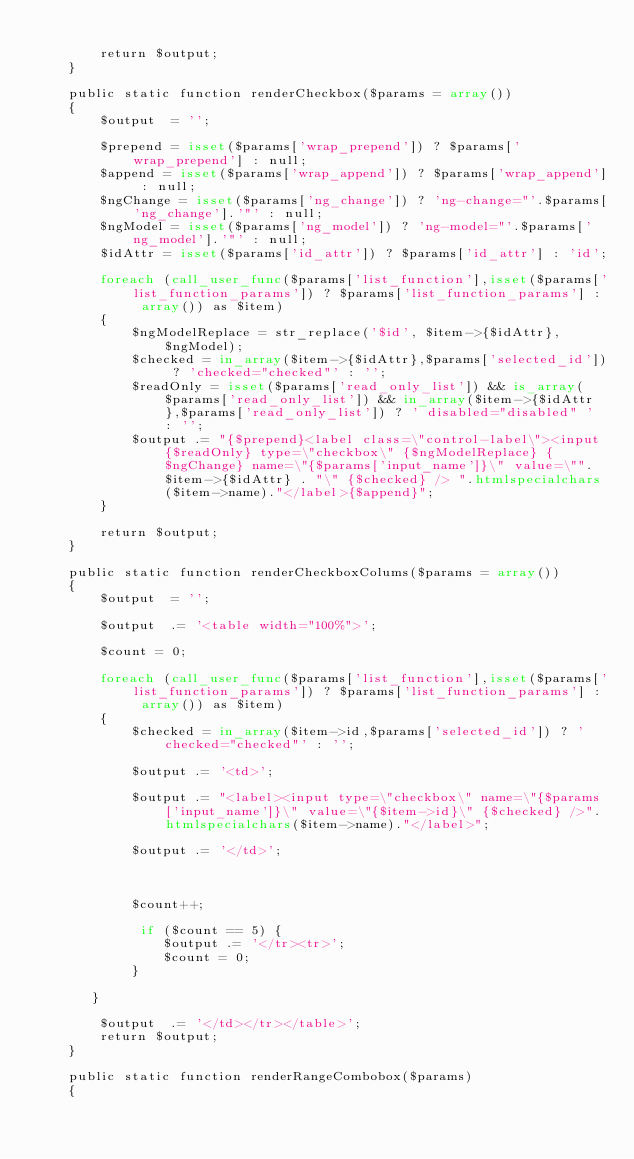<code> <loc_0><loc_0><loc_500><loc_500><_PHP_>
        return $output;
    }

    public static function renderCheckbox($params = array())
    {
        $output  = '';

        $prepend = isset($params['wrap_prepend']) ? $params['wrap_prepend'] : null;
        $append = isset($params['wrap_append']) ? $params['wrap_append'] : null;
        $ngChange = isset($params['ng_change']) ? 'ng-change="'.$params['ng_change'].'"' : null;
        $ngModel = isset($params['ng_model']) ? 'ng-model="'.$params['ng_model'].'"' : null;
        $idAttr = isset($params['id_attr']) ? $params['id_attr'] : 'id';

        foreach (call_user_func($params['list_function'],isset($params['list_function_params']) ? $params['list_function_params'] : array()) as $item)
        {
            $ngModelReplace = str_replace('$id', $item->{$idAttr}, $ngModel);
            $checked = in_array($item->{$idAttr},$params['selected_id']) ? 'checked="checked"' : '';
            $readOnly = isset($params['read_only_list']) && is_array($params['read_only_list']) && in_array($item->{$idAttr},$params['read_only_list']) ? ' disabled="disabled" ' : '';
            $output .= "{$prepend}<label class=\"control-label\"><input {$readOnly} type=\"checkbox\" {$ngModelReplace} {$ngChange} name=\"{$params['input_name']}\" value=\"". $item->{$idAttr} . "\" {$checked} /> ".htmlspecialchars($item->name)."</label>{$append}";
        }

        return $output;
    }

    public static function renderCheckboxColums($params = array())
    {
        $output  = '';

        $output  .= '<table width="100%">';

        $count = 0;

        foreach (call_user_func($params['list_function'],isset($params['list_function_params']) ? $params['list_function_params'] : array()) as $item)
        {
            $checked = in_array($item->id,$params['selected_id']) ? 'checked="checked"' : '';

            $output .= '<td>';

            $output .= "<label><input type=\"checkbox\" name=\"{$params['input_name']}\" value=\"{$item->id}\" {$checked} />".htmlspecialchars($item->name)."</label>";

            $output .= '</td>';



            $count++;

             if ($count == 5) {
            	$output .= '</tr><tr>';
            	$count = 0;
            }

       }

        $output  .= '</td></tr></table>';
        return $output;
    }

    public static function renderRangeCombobox($params)
    {</code> 